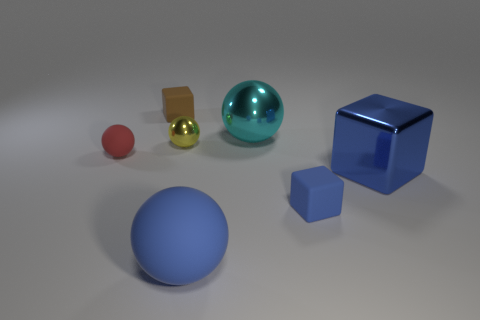Subtract 1 spheres. How many spheres are left? 3 Add 1 small red balls. How many objects exist? 8 Subtract all brown spheres. Subtract all brown cubes. How many spheres are left? 4 Subtract all balls. How many objects are left? 3 Add 2 large red cylinders. How many large red cylinders exist? 2 Subtract 0 yellow cylinders. How many objects are left? 7 Subtract all big cyan matte cubes. Subtract all tiny yellow shiny things. How many objects are left? 6 Add 6 tiny brown cubes. How many tiny brown cubes are left? 7 